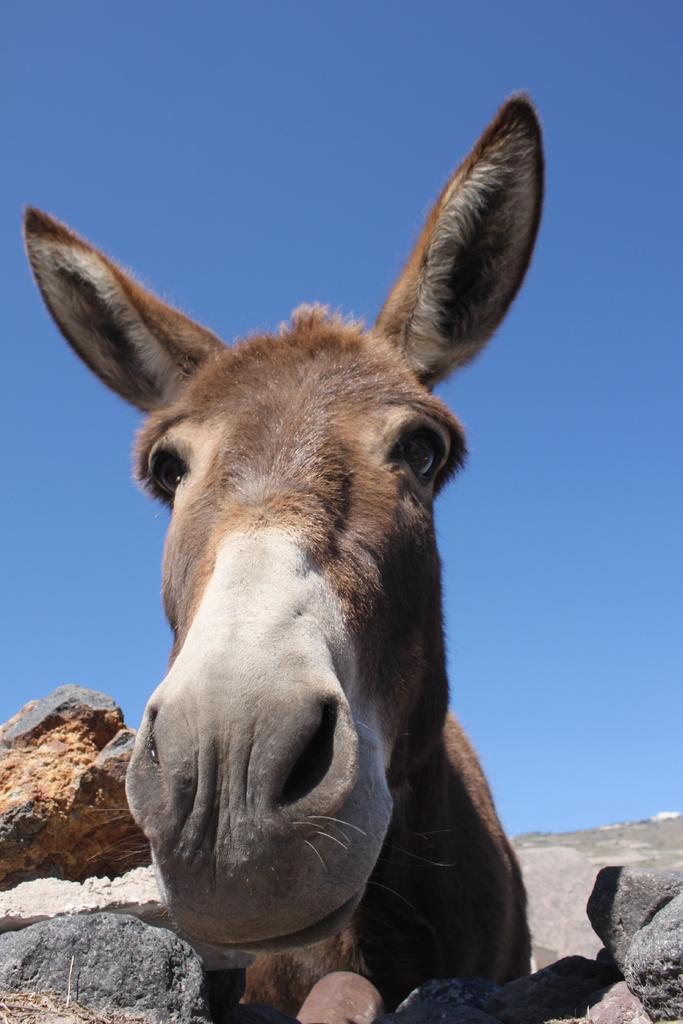What is located in the center of the image? There are rocks and a donkey in the center of the image. Can you describe the donkey in the image? The donkey is in ash and brown color. What can be seen in the background of the image? There is sky visible in the background of the image, along with other objects. What type of pies is the band playing in the background of the image? There is no band or pies present in the image; it features rocks and a donkey in the center, with sky and other objects in the background. 